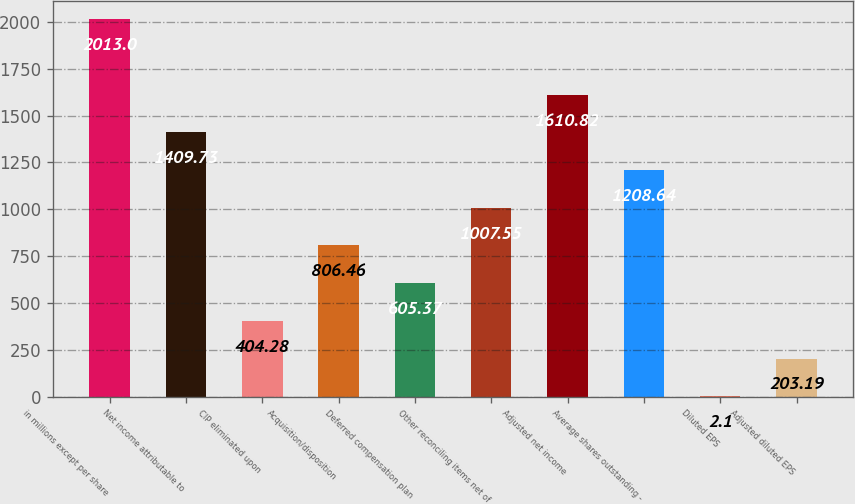Convert chart to OTSL. <chart><loc_0><loc_0><loc_500><loc_500><bar_chart><fcel>in millions except per share<fcel>Net income attributable to<fcel>CIP eliminated upon<fcel>Acquisition/disposition<fcel>Deferred compensation plan<fcel>Other reconciling items net of<fcel>Adjusted net income<fcel>Average shares outstanding -<fcel>Diluted EPS<fcel>Adjusted diluted EPS<nl><fcel>2013<fcel>1409.73<fcel>404.28<fcel>806.46<fcel>605.37<fcel>1007.55<fcel>1610.82<fcel>1208.64<fcel>2.1<fcel>203.19<nl></chart> 